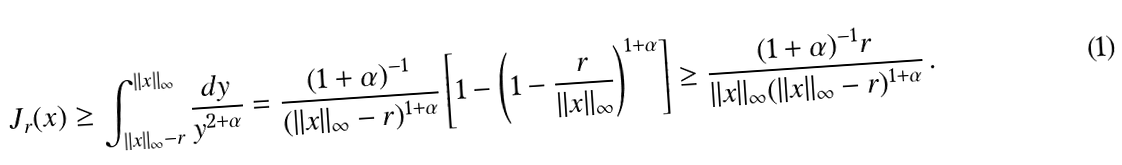<formula> <loc_0><loc_0><loc_500><loc_500>J _ { r } ( x ) \geq \int _ { \| x \| _ { \infty } - r } ^ { \| x \| _ { \infty } } \frac { d y } { y ^ { 2 + \alpha } } = \frac { ( 1 + \alpha ) ^ { - 1 } } { ( \| x \| _ { \infty } - r ) ^ { 1 + \alpha } } \left [ 1 - \left ( 1 - \frac { r } { \| x \| _ { \infty } } \right ) ^ { 1 + \alpha } \right ] \geq \frac { ( 1 + \alpha ) ^ { - 1 } r } { \| x \| _ { \infty } ( \| x \| _ { \infty } - r ) ^ { 1 + \alpha } } \, .</formula> 